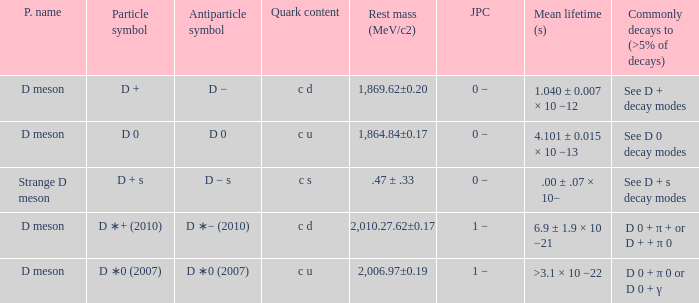What is the j p c that commonly decays (>5% of decays) d 0 + π 0 or d 0 + γ? 1 −. 